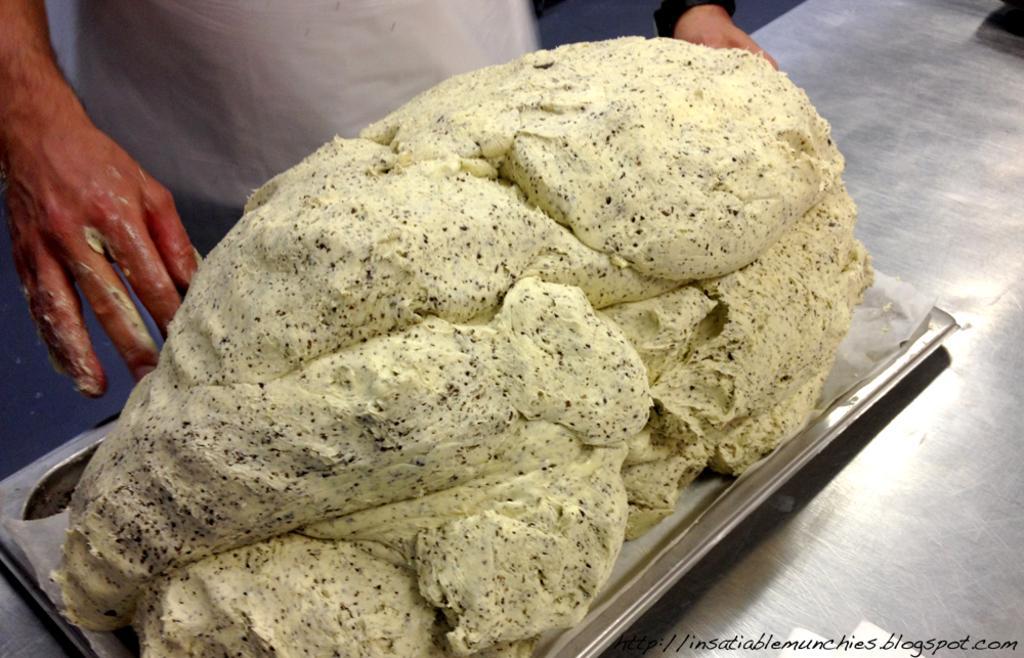Could you give a brief overview of what you see in this image? In this picture there is a person standing behind the table. There is a dough on the plate. There is a plate on the table. In the bottom right there is a text. 